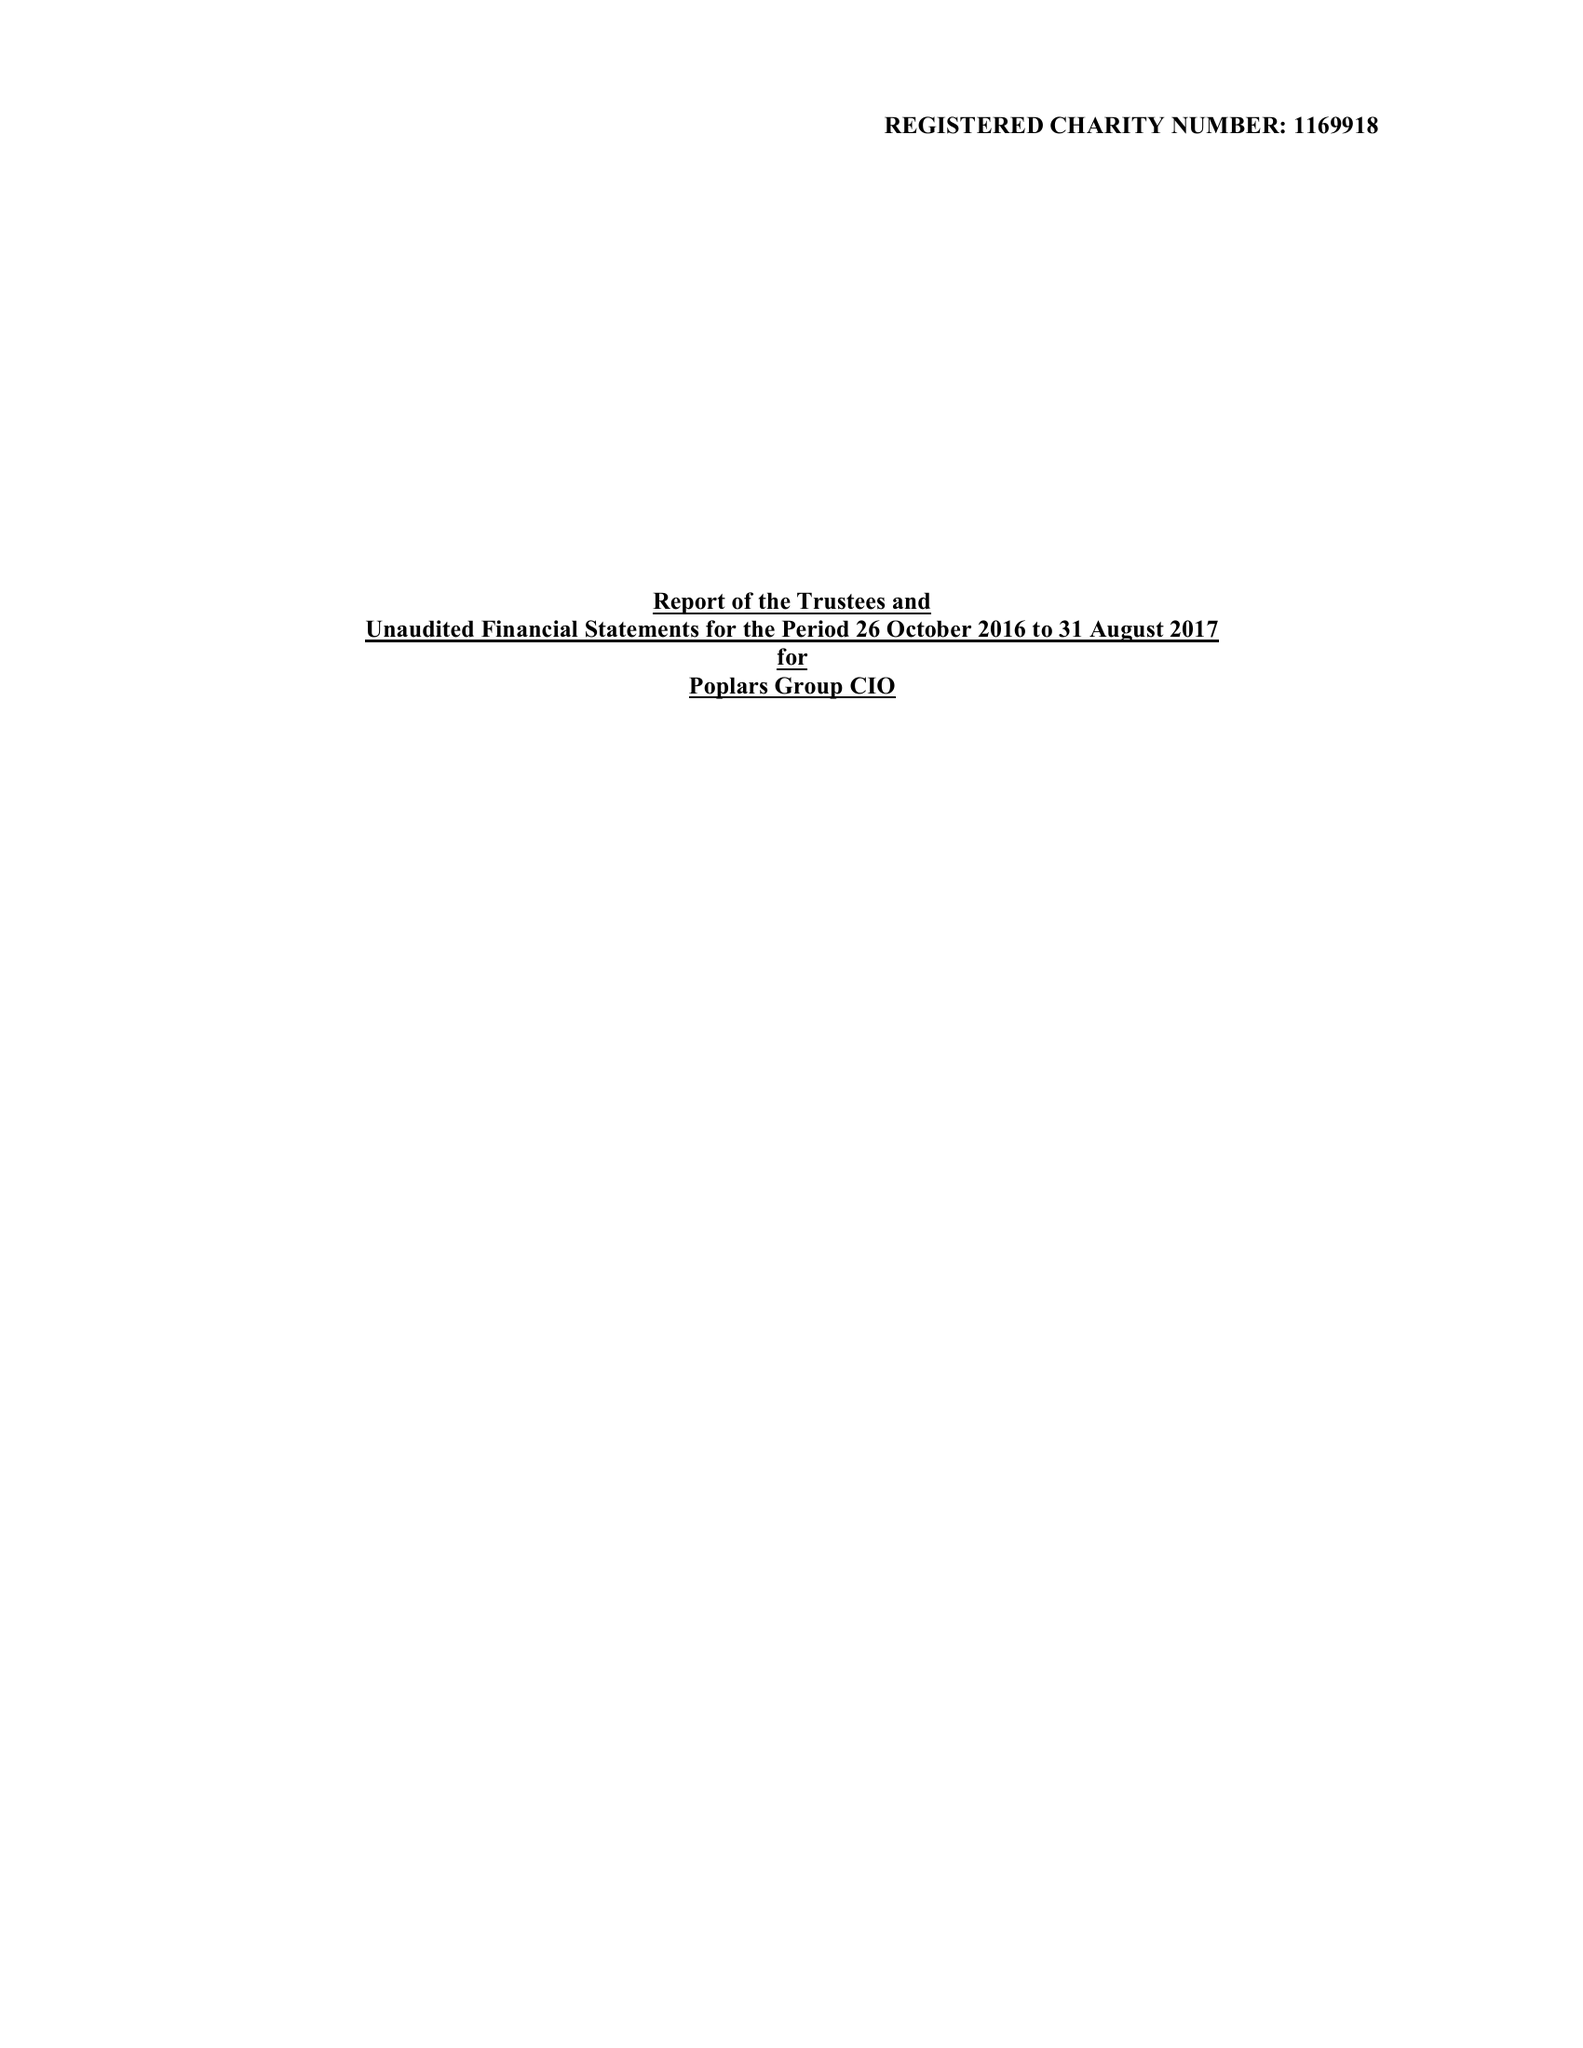What is the value for the income_annually_in_british_pounds?
Answer the question using a single word or phrase. None 